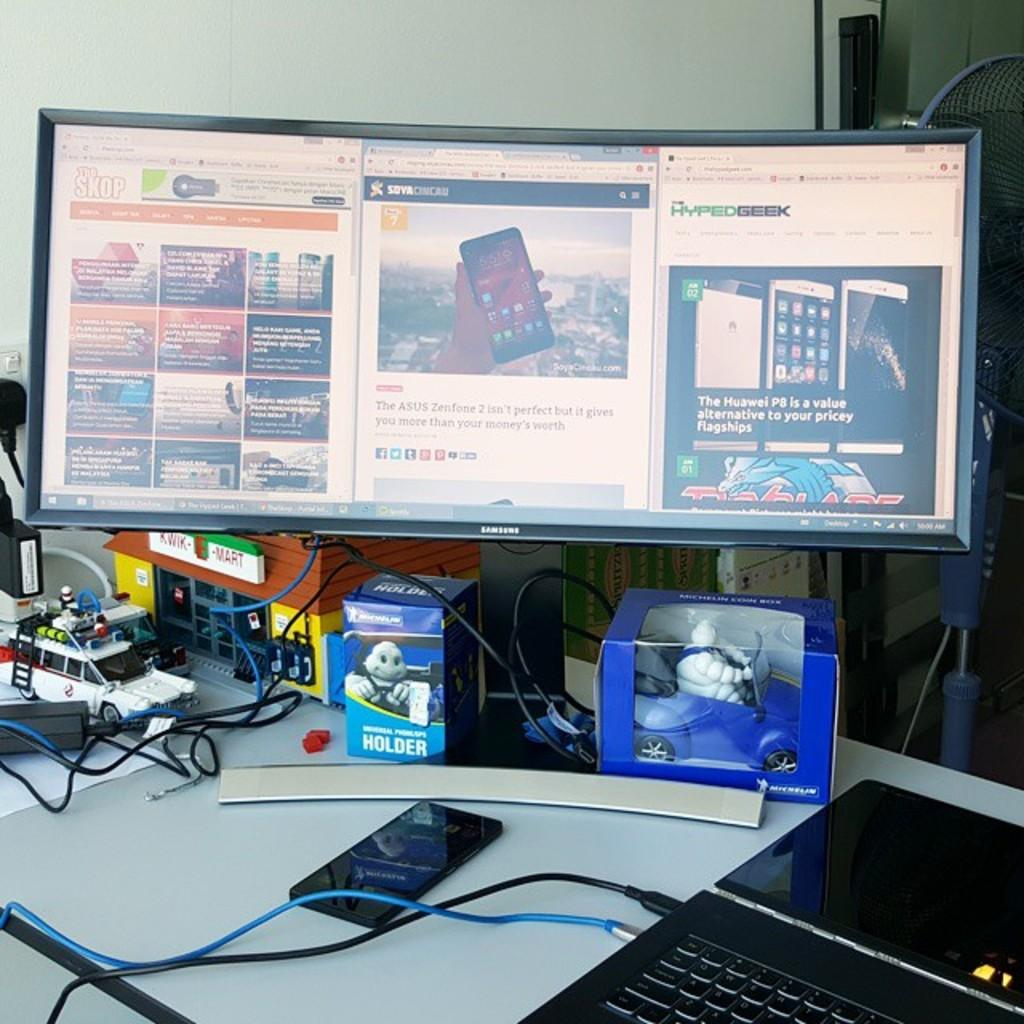<image>
Describe the image concisely. the word value is on the computer screen 